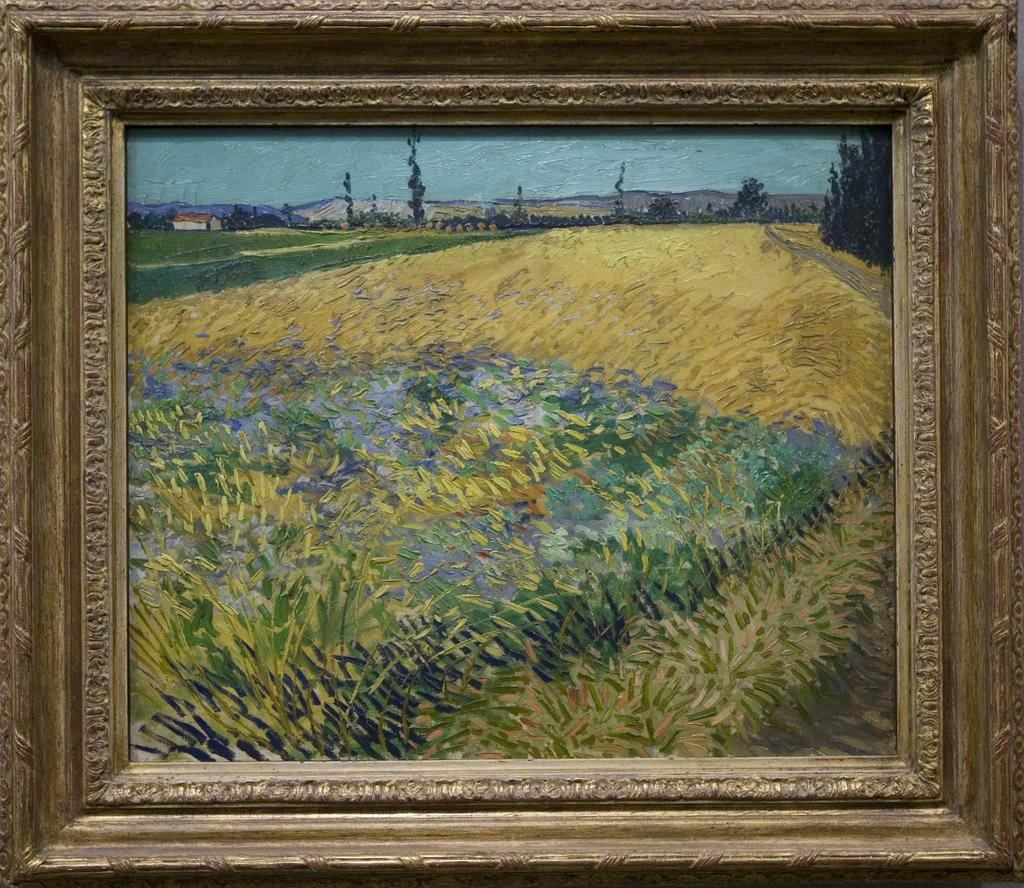What is one of the objects visible in the image? There is a photo frame in the image. What type of artwork is present in the image? There is an abstract painting in the image. What type of vest is being exchanged in the image? There is no vest or exchange of any kind present in the image. How many rays can be seen emanating from the abstract painting? There are no rays visible in the image; it only features a photo frame and an abstract painting. 